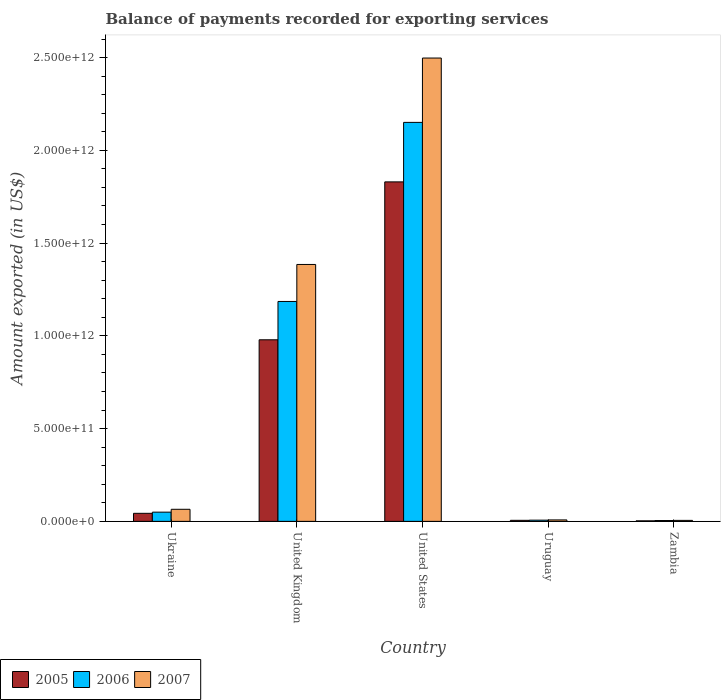Are the number of bars on each tick of the X-axis equal?
Your answer should be compact. Yes. How many bars are there on the 5th tick from the right?
Offer a very short reply. 3. What is the label of the 2nd group of bars from the left?
Your answer should be very brief. United Kingdom. What is the amount exported in 2007 in United Kingdom?
Provide a short and direct response. 1.38e+12. Across all countries, what is the maximum amount exported in 2005?
Provide a short and direct response. 1.83e+12. Across all countries, what is the minimum amount exported in 2005?
Keep it short and to the point. 2.84e+09. In which country was the amount exported in 2005 minimum?
Provide a succinct answer. Zambia. What is the total amount exported in 2005 in the graph?
Provide a short and direct response. 2.86e+12. What is the difference between the amount exported in 2006 in Ukraine and that in United Kingdom?
Your answer should be compact. -1.14e+12. What is the difference between the amount exported in 2006 in Uruguay and the amount exported in 2007 in United States?
Keep it short and to the point. -2.49e+12. What is the average amount exported in 2007 per country?
Provide a succinct answer. 7.92e+11. What is the difference between the amount exported of/in 2005 and amount exported of/in 2006 in United States?
Ensure brevity in your answer.  -3.21e+11. In how many countries, is the amount exported in 2007 greater than 100000000000 US$?
Offer a terse response. 2. What is the ratio of the amount exported in 2006 in Ukraine to that in Zambia?
Provide a short and direct response. 10.88. Is the amount exported in 2005 in Ukraine less than that in United Kingdom?
Your answer should be compact. Yes. What is the difference between the highest and the second highest amount exported in 2005?
Offer a terse response. 8.51e+11. What is the difference between the highest and the lowest amount exported in 2007?
Make the answer very short. 2.49e+12. What does the 2nd bar from the right in Ukraine represents?
Offer a terse response. 2006. Is it the case that in every country, the sum of the amount exported in 2005 and amount exported in 2007 is greater than the amount exported in 2006?
Your answer should be very brief. Yes. Are all the bars in the graph horizontal?
Offer a very short reply. No. How many countries are there in the graph?
Your answer should be compact. 5. What is the difference between two consecutive major ticks on the Y-axis?
Provide a succinct answer. 5.00e+11. Does the graph contain any zero values?
Offer a very short reply. No. Where does the legend appear in the graph?
Offer a very short reply. Bottom left. What is the title of the graph?
Give a very brief answer. Balance of payments recorded for exporting services. What is the label or title of the Y-axis?
Your answer should be compact. Amount exported (in US$). What is the Amount exported (in US$) of 2005 in Ukraine?
Offer a terse response. 4.34e+1. What is the Amount exported (in US$) of 2006 in Ukraine?
Offer a very short reply. 4.97e+1. What is the Amount exported (in US$) of 2007 in Ukraine?
Your response must be concise. 6.51e+1. What is the Amount exported (in US$) in 2005 in United Kingdom?
Offer a very short reply. 9.79e+11. What is the Amount exported (in US$) in 2006 in United Kingdom?
Provide a succinct answer. 1.19e+12. What is the Amount exported (in US$) of 2007 in United Kingdom?
Your response must be concise. 1.38e+12. What is the Amount exported (in US$) in 2005 in United States?
Offer a very short reply. 1.83e+12. What is the Amount exported (in US$) of 2006 in United States?
Offer a terse response. 2.15e+12. What is the Amount exported (in US$) in 2007 in United States?
Ensure brevity in your answer.  2.50e+12. What is the Amount exported (in US$) in 2005 in Uruguay?
Offer a terse response. 5.65e+09. What is the Amount exported (in US$) of 2006 in Uruguay?
Provide a succinct answer. 6.53e+09. What is the Amount exported (in US$) in 2007 in Uruguay?
Make the answer very short. 7.82e+09. What is the Amount exported (in US$) of 2005 in Zambia?
Your answer should be compact. 2.84e+09. What is the Amount exported (in US$) in 2006 in Zambia?
Give a very brief answer. 4.57e+09. What is the Amount exported (in US$) of 2007 in Zambia?
Keep it short and to the point. 5.26e+09. Across all countries, what is the maximum Amount exported (in US$) of 2005?
Offer a terse response. 1.83e+12. Across all countries, what is the maximum Amount exported (in US$) in 2006?
Provide a succinct answer. 2.15e+12. Across all countries, what is the maximum Amount exported (in US$) in 2007?
Provide a short and direct response. 2.50e+12. Across all countries, what is the minimum Amount exported (in US$) of 2005?
Provide a short and direct response. 2.84e+09. Across all countries, what is the minimum Amount exported (in US$) in 2006?
Give a very brief answer. 4.57e+09. Across all countries, what is the minimum Amount exported (in US$) in 2007?
Your answer should be very brief. 5.26e+09. What is the total Amount exported (in US$) in 2005 in the graph?
Provide a succinct answer. 2.86e+12. What is the total Amount exported (in US$) in 2006 in the graph?
Offer a very short reply. 3.40e+12. What is the total Amount exported (in US$) of 2007 in the graph?
Make the answer very short. 3.96e+12. What is the difference between the Amount exported (in US$) in 2005 in Ukraine and that in United Kingdom?
Your response must be concise. -9.35e+11. What is the difference between the Amount exported (in US$) in 2006 in Ukraine and that in United Kingdom?
Offer a terse response. -1.14e+12. What is the difference between the Amount exported (in US$) of 2007 in Ukraine and that in United Kingdom?
Ensure brevity in your answer.  -1.32e+12. What is the difference between the Amount exported (in US$) of 2005 in Ukraine and that in United States?
Your answer should be very brief. -1.79e+12. What is the difference between the Amount exported (in US$) of 2006 in Ukraine and that in United States?
Keep it short and to the point. -2.10e+12. What is the difference between the Amount exported (in US$) of 2007 in Ukraine and that in United States?
Provide a short and direct response. -2.43e+12. What is the difference between the Amount exported (in US$) in 2005 in Ukraine and that in Uruguay?
Provide a succinct answer. 3.77e+1. What is the difference between the Amount exported (in US$) in 2006 in Ukraine and that in Uruguay?
Your answer should be compact. 4.32e+1. What is the difference between the Amount exported (in US$) of 2007 in Ukraine and that in Uruguay?
Keep it short and to the point. 5.72e+1. What is the difference between the Amount exported (in US$) of 2005 in Ukraine and that in Zambia?
Provide a succinct answer. 4.05e+1. What is the difference between the Amount exported (in US$) of 2006 in Ukraine and that in Zambia?
Provide a succinct answer. 4.51e+1. What is the difference between the Amount exported (in US$) of 2007 in Ukraine and that in Zambia?
Offer a terse response. 5.98e+1. What is the difference between the Amount exported (in US$) in 2005 in United Kingdom and that in United States?
Your answer should be compact. -8.51e+11. What is the difference between the Amount exported (in US$) of 2006 in United Kingdom and that in United States?
Your response must be concise. -9.65e+11. What is the difference between the Amount exported (in US$) of 2007 in United Kingdom and that in United States?
Give a very brief answer. -1.11e+12. What is the difference between the Amount exported (in US$) in 2005 in United Kingdom and that in Uruguay?
Keep it short and to the point. 9.73e+11. What is the difference between the Amount exported (in US$) of 2006 in United Kingdom and that in Uruguay?
Offer a terse response. 1.18e+12. What is the difference between the Amount exported (in US$) of 2007 in United Kingdom and that in Uruguay?
Ensure brevity in your answer.  1.38e+12. What is the difference between the Amount exported (in US$) of 2005 in United Kingdom and that in Zambia?
Your answer should be very brief. 9.76e+11. What is the difference between the Amount exported (in US$) in 2006 in United Kingdom and that in Zambia?
Ensure brevity in your answer.  1.18e+12. What is the difference between the Amount exported (in US$) in 2007 in United Kingdom and that in Zambia?
Your answer should be compact. 1.38e+12. What is the difference between the Amount exported (in US$) in 2005 in United States and that in Uruguay?
Your response must be concise. 1.82e+12. What is the difference between the Amount exported (in US$) in 2006 in United States and that in Uruguay?
Give a very brief answer. 2.14e+12. What is the difference between the Amount exported (in US$) in 2007 in United States and that in Uruguay?
Offer a very short reply. 2.49e+12. What is the difference between the Amount exported (in US$) in 2005 in United States and that in Zambia?
Your response must be concise. 1.83e+12. What is the difference between the Amount exported (in US$) in 2006 in United States and that in Zambia?
Give a very brief answer. 2.15e+12. What is the difference between the Amount exported (in US$) in 2007 in United States and that in Zambia?
Provide a short and direct response. 2.49e+12. What is the difference between the Amount exported (in US$) in 2005 in Uruguay and that in Zambia?
Your response must be concise. 2.81e+09. What is the difference between the Amount exported (in US$) in 2006 in Uruguay and that in Zambia?
Ensure brevity in your answer.  1.96e+09. What is the difference between the Amount exported (in US$) in 2007 in Uruguay and that in Zambia?
Give a very brief answer. 2.56e+09. What is the difference between the Amount exported (in US$) of 2005 in Ukraine and the Amount exported (in US$) of 2006 in United Kingdom?
Offer a very short reply. -1.14e+12. What is the difference between the Amount exported (in US$) in 2005 in Ukraine and the Amount exported (in US$) in 2007 in United Kingdom?
Keep it short and to the point. -1.34e+12. What is the difference between the Amount exported (in US$) in 2006 in Ukraine and the Amount exported (in US$) in 2007 in United Kingdom?
Ensure brevity in your answer.  -1.34e+12. What is the difference between the Amount exported (in US$) of 2005 in Ukraine and the Amount exported (in US$) of 2006 in United States?
Give a very brief answer. -2.11e+12. What is the difference between the Amount exported (in US$) of 2005 in Ukraine and the Amount exported (in US$) of 2007 in United States?
Your answer should be very brief. -2.45e+12. What is the difference between the Amount exported (in US$) in 2006 in Ukraine and the Amount exported (in US$) in 2007 in United States?
Give a very brief answer. -2.45e+12. What is the difference between the Amount exported (in US$) of 2005 in Ukraine and the Amount exported (in US$) of 2006 in Uruguay?
Keep it short and to the point. 3.69e+1. What is the difference between the Amount exported (in US$) in 2005 in Ukraine and the Amount exported (in US$) in 2007 in Uruguay?
Your response must be concise. 3.56e+1. What is the difference between the Amount exported (in US$) of 2006 in Ukraine and the Amount exported (in US$) of 2007 in Uruguay?
Ensure brevity in your answer.  4.19e+1. What is the difference between the Amount exported (in US$) of 2005 in Ukraine and the Amount exported (in US$) of 2006 in Zambia?
Give a very brief answer. 3.88e+1. What is the difference between the Amount exported (in US$) in 2005 in Ukraine and the Amount exported (in US$) in 2007 in Zambia?
Your answer should be very brief. 3.81e+1. What is the difference between the Amount exported (in US$) of 2006 in Ukraine and the Amount exported (in US$) of 2007 in Zambia?
Keep it short and to the point. 4.44e+1. What is the difference between the Amount exported (in US$) of 2005 in United Kingdom and the Amount exported (in US$) of 2006 in United States?
Keep it short and to the point. -1.17e+12. What is the difference between the Amount exported (in US$) of 2005 in United Kingdom and the Amount exported (in US$) of 2007 in United States?
Your answer should be compact. -1.52e+12. What is the difference between the Amount exported (in US$) in 2006 in United Kingdom and the Amount exported (in US$) in 2007 in United States?
Your response must be concise. -1.31e+12. What is the difference between the Amount exported (in US$) in 2005 in United Kingdom and the Amount exported (in US$) in 2006 in Uruguay?
Provide a short and direct response. 9.72e+11. What is the difference between the Amount exported (in US$) in 2005 in United Kingdom and the Amount exported (in US$) in 2007 in Uruguay?
Your answer should be compact. 9.71e+11. What is the difference between the Amount exported (in US$) in 2006 in United Kingdom and the Amount exported (in US$) in 2007 in Uruguay?
Give a very brief answer. 1.18e+12. What is the difference between the Amount exported (in US$) in 2005 in United Kingdom and the Amount exported (in US$) in 2006 in Zambia?
Keep it short and to the point. 9.74e+11. What is the difference between the Amount exported (in US$) in 2005 in United Kingdom and the Amount exported (in US$) in 2007 in Zambia?
Offer a terse response. 9.74e+11. What is the difference between the Amount exported (in US$) of 2006 in United Kingdom and the Amount exported (in US$) of 2007 in Zambia?
Your response must be concise. 1.18e+12. What is the difference between the Amount exported (in US$) in 2005 in United States and the Amount exported (in US$) in 2006 in Uruguay?
Your response must be concise. 1.82e+12. What is the difference between the Amount exported (in US$) in 2005 in United States and the Amount exported (in US$) in 2007 in Uruguay?
Keep it short and to the point. 1.82e+12. What is the difference between the Amount exported (in US$) of 2006 in United States and the Amount exported (in US$) of 2007 in Uruguay?
Your answer should be compact. 2.14e+12. What is the difference between the Amount exported (in US$) of 2005 in United States and the Amount exported (in US$) of 2006 in Zambia?
Offer a very short reply. 1.83e+12. What is the difference between the Amount exported (in US$) in 2005 in United States and the Amount exported (in US$) in 2007 in Zambia?
Offer a very short reply. 1.82e+12. What is the difference between the Amount exported (in US$) in 2006 in United States and the Amount exported (in US$) in 2007 in Zambia?
Provide a succinct answer. 2.15e+12. What is the difference between the Amount exported (in US$) in 2005 in Uruguay and the Amount exported (in US$) in 2006 in Zambia?
Your response must be concise. 1.08e+09. What is the difference between the Amount exported (in US$) in 2005 in Uruguay and the Amount exported (in US$) in 2007 in Zambia?
Your answer should be very brief. 3.86e+08. What is the difference between the Amount exported (in US$) of 2006 in Uruguay and the Amount exported (in US$) of 2007 in Zambia?
Your response must be concise. 1.27e+09. What is the average Amount exported (in US$) of 2005 per country?
Your answer should be compact. 5.72e+11. What is the average Amount exported (in US$) of 2006 per country?
Offer a very short reply. 6.79e+11. What is the average Amount exported (in US$) in 2007 per country?
Offer a very short reply. 7.92e+11. What is the difference between the Amount exported (in US$) of 2005 and Amount exported (in US$) of 2006 in Ukraine?
Provide a succinct answer. -6.30e+09. What is the difference between the Amount exported (in US$) of 2005 and Amount exported (in US$) of 2007 in Ukraine?
Your answer should be very brief. -2.17e+1. What is the difference between the Amount exported (in US$) of 2006 and Amount exported (in US$) of 2007 in Ukraine?
Your answer should be compact. -1.54e+1. What is the difference between the Amount exported (in US$) of 2005 and Amount exported (in US$) of 2006 in United Kingdom?
Your answer should be compact. -2.07e+11. What is the difference between the Amount exported (in US$) of 2005 and Amount exported (in US$) of 2007 in United Kingdom?
Give a very brief answer. -4.06e+11. What is the difference between the Amount exported (in US$) of 2006 and Amount exported (in US$) of 2007 in United Kingdom?
Ensure brevity in your answer.  -1.99e+11. What is the difference between the Amount exported (in US$) in 2005 and Amount exported (in US$) in 2006 in United States?
Your answer should be very brief. -3.21e+11. What is the difference between the Amount exported (in US$) of 2005 and Amount exported (in US$) of 2007 in United States?
Offer a terse response. -6.68e+11. What is the difference between the Amount exported (in US$) of 2006 and Amount exported (in US$) of 2007 in United States?
Provide a succinct answer. -3.47e+11. What is the difference between the Amount exported (in US$) of 2005 and Amount exported (in US$) of 2006 in Uruguay?
Your response must be concise. -8.80e+08. What is the difference between the Amount exported (in US$) in 2005 and Amount exported (in US$) in 2007 in Uruguay?
Provide a short and direct response. -2.17e+09. What is the difference between the Amount exported (in US$) of 2006 and Amount exported (in US$) of 2007 in Uruguay?
Your response must be concise. -1.29e+09. What is the difference between the Amount exported (in US$) in 2005 and Amount exported (in US$) in 2006 in Zambia?
Your answer should be very brief. -1.73e+09. What is the difference between the Amount exported (in US$) in 2005 and Amount exported (in US$) in 2007 in Zambia?
Ensure brevity in your answer.  -2.42e+09. What is the difference between the Amount exported (in US$) of 2006 and Amount exported (in US$) of 2007 in Zambia?
Your answer should be compact. -6.96e+08. What is the ratio of the Amount exported (in US$) in 2005 in Ukraine to that in United Kingdom?
Give a very brief answer. 0.04. What is the ratio of the Amount exported (in US$) in 2006 in Ukraine to that in United Kingdom?
Your answer should be compact. 0.04. What is the ratio of the Amount exported (in US$) of 2007 in Ukraine to that in United Kingdom?
Make the answer very short. 0.05. What is the ratio of the Amount exported (in US$) in 2005 in Ukraine to that in United States?
Ensure brevity in your answer.  0.02. What is the ratio of the Amount exported (in US$) in 2006 in Ukraine to that in United States?
Keep it short and to the point. 0.02. What is the ratio of the Amount exported (in US$) in 2007 in Ukraine to that in United States?
Your answer should be very brief. 0.03. What is the ratio of the Amount exported (in US$) of 2005 in Ukraine to that in Uruguay?
Give a very brief answer. 7.68. What is the ratio of the Amount exported (in US$) of 2006 in Ukraine to that in Uruguay?
Make the answer very short. 7.61. What is the ratio of the Amount exported (in US$) of 2007 in Ukraine to that in Uruguay?
Your response must be concise. 8.32. What is the ratio of the Amount exported (in US$) in 2005 in Ukraine to that in Zambia?
Make the answer very short. 15.27. What is the ratio of the Amount exported (in US$) of 2006 in Ukraine to that in Zambia?
Offer a very short reply. 10.88. What is the ratio of the Amount exported (in US$) of 2007 in Ukraine to that in Zambia?
Make the answer very short. 12.36. What is the ratio of the Amount exported (in US$) in 2005 in United Kingdom to that in United States?
Provide a succinct answer. 0.53. What is the ratio of the Amount exported (in US$) in 2006 in United Kingdom to that in United States?
Offer a terse response. 0.55. What is the ratio of the Amount exported (in US$) of 2007 in United Kingdom to that in United States?
Your answer should be compact. 0.55. What is the ratio of the Amount exported (in US$) of 2005 in United Kingdom to that in Uruguay?
Offer a very short reply. 173.29. What is the ratio of the Amount exported (in US$) of 2006 in United Kingdom to that in Uruguay?
Ensure brevity in your answer.  181.56. What is the ratio of the Amount exported (in US$) in 2007 in United Kingdom to that in Uruguay?
Make the answer very short. 177.13. What is the ratio of the Amount exported (in US$) of 2005 in United Kingdom to that in Zambia?
Ensure brevity in your answer.  344.46. What is the ratio of the Amount exported (in US$) of 2006 in United Kingdom to that in Zambia?
Make the answer very short. 259.57. What is the ratio of the Amount exported (in US$) in 2007 in United Kingdom to that in Zambia?
Ensure brevity in your answer.  263.16. What is the ratio of the Amount exported (in US$) in 2005 in United States to that in Uruguay?
Keep it short and to the point. 323.98. What is the ratio of the Amount exported (in US$) of 2006 in United States to that in Uruguay?
Provide a short and direct response. 329.42. What is the ratio of the Amount exported (in US$) of 2007 in United States to that in Uruguay?
Provide a succinct answer. 319.45. What is the ratio of the Amount exported (in US$) in 2005 in United States to that in Zambia?
Your response must be concise. 644. What is the ratio of the Amount exported (in US$) in 2006 in United States to that in Zambia?
Provide a succinct answer. 470.95. What is the ratio of the Amount exported (in US$) of 2007 in United States to that in Zambia?
Offer a very short reply. 474.61. What is the ratio of the Amount exported (in US$) in 2005 in Uruguay to that in Zambia?
Your response must be concise. 1.99. What is the ratio of the Amount exported (in US$) in 2006 in Uruguay to that in Zambia?
Provide a short and direct response. 1.43. What is the ratio of the Amount exported (in US$) of 2007 in Uruguay to that in Zambia?
Provide a short and direct response. 1.49. What is the difference between the highest and the second highest Amount exported (in US$) in 2005?
Your response must be concise. 8.51e+11. What is the difference between the highest and the second highest Amount exported (in US$) of 2006?
Keep it short and to the point. 9.65e+11. What is the difference between the highest and the second highest Amount exported (in US$) of 2007?
Your answer should be compact. 1.11e+12. What is the difference between the highest and the lowest Amount exported (in US$) of 2005?
Your answer should be compact. 1.83e+12. What is the difference between the highest and the lowest Amount exported (in US$) in 2006?
Keep it short and to the point. 2.15e+12. What is the difference between the highest and the lowest Amount exported (in US$) in 2007?
Offer a terse response. 2.49e+12. 